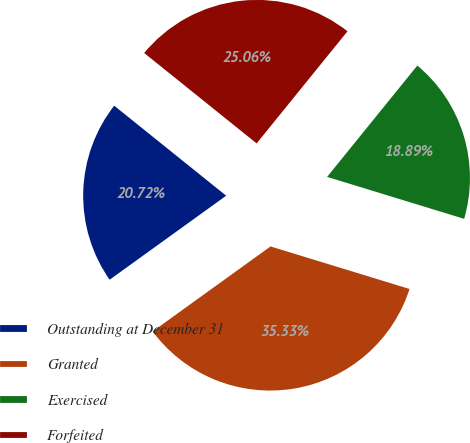<chart> <loc_0><loc_0><loc_500><loc_500><pie_chart><fcel>Outstanding at December 31<fcel>Granted<fcel>Exercised<fcel>Forfeited<nl><fcel>20.72%<fcel>35.33%<fcel>18.89%<fcel>25.06%<nl></chart> 